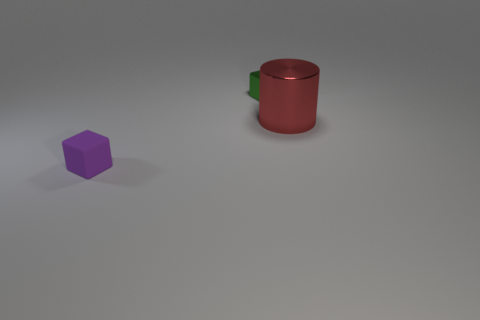What is the size of the object that is both right of the purple cube and in front of the shiny block?
Your answer should be compact. Large. Are there fewer small purple matte objects that are in front of the purple block than small purple rubber things?
Provide a succinct answer. Yes. There is a tiny object that is made of the same material as the large red cylinder; what shape is it?
Your answer should be compact. Cube. Is the purple thing made of the same material as the small green object?
Give a very brief answer. No. Is the number of things that are right of the tiny purple block less than the number of metallic objects in front of the metal cylinder?
Offer a very short reply. No. How many purple objects are on the left side of the shiny object in front of the small cube behind the tiny purple cube?
Offer a terse response. 1. There is another matte thing that is the same size as the green object; what color is it?
Your response must be concise. Purple. Is there a blue object that has the same shape as the purple rubber thing?
Give a very brief answer. No. There is a big shiny object right of the tiny cube that is to the right of the purple object; is there a shiny thing to the left of it?
Provide a short and direct response. Yes. There is another matte object that is the same shape as the small green thing; what is its color?
Offer a very short reply. Purple. 